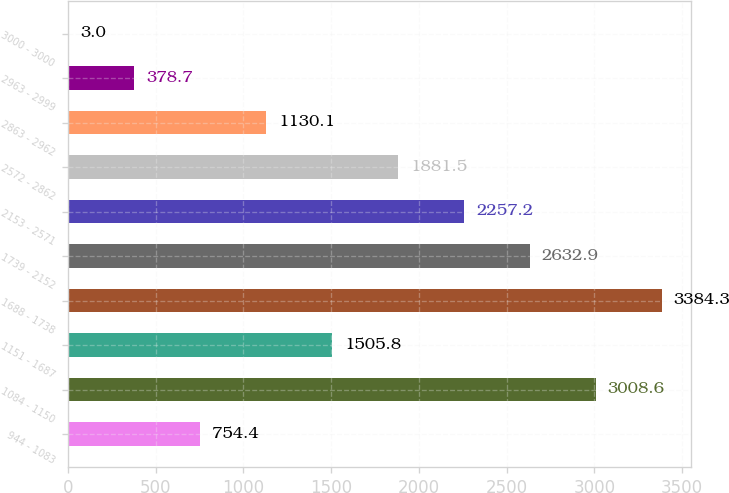Convert chart to OTSL. <chart><loc_0><loc_0><loc_500><loc_500><bar_chart><fcel>944 - 1083<fcel>1084 - 1150<fcel>1151 - 1687<fcel>1688 - 1738<fcel>1739 - 2152<fcel>2153 - 2571<fcel>2572 - 2862<fcel>2863 - 2962<fcel>2963 - 2999<fcel>3000 - 3000<nl><fcel>754.4<fcel>3008.6<fcel>1505.8<fcel>3384.3<fcel>2632.9<fcel>2257.2<fcel>1881.5<fcel>1130.1<fcel>378.7<fcel>3<nl></chart> 